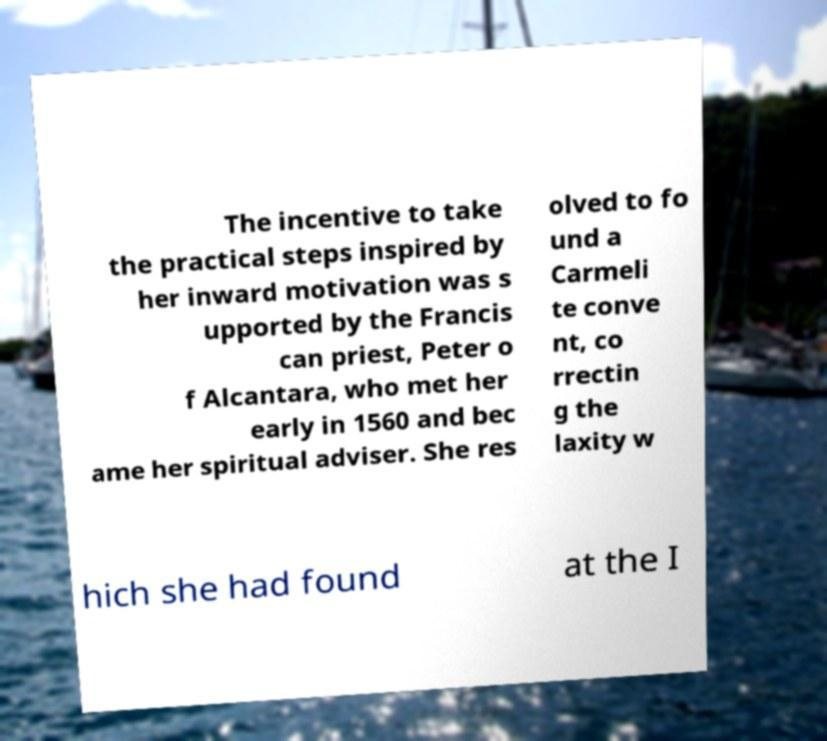Can you read and provide the text displayed in the image? This photo seems to have some interesting text. Can you extract and type it out for me? The text in the image appears to be incomplete, but from what is legible, it reads: 'The incentive to take the practical steps inspired by her inward motivation was supported by the Franciscan priest, Peter of Alcantara, who met her early in 1560 and became her spiritual adviser. She resolved to found a Carmelite convent, correcting the laxity which she had found at the [text cut off].' Unfortunately, due to the cut-off text, I cannot provide the continuation beyond this point. 